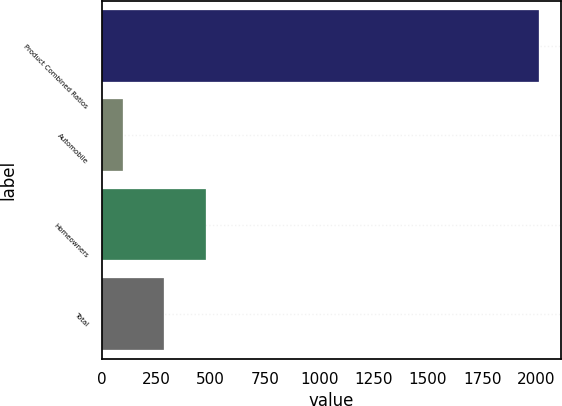Convert chart. <chart><loc_0><loc_0><loc_500><loc_500><bar_chart><fcel>Product Combined Ratios<fcel>Automobile<fcel>Homeowners<fcel>Total<nl><fcel>2011<fcel>95.3<fcel>478.44<fcel>286.87<nl></chart> 